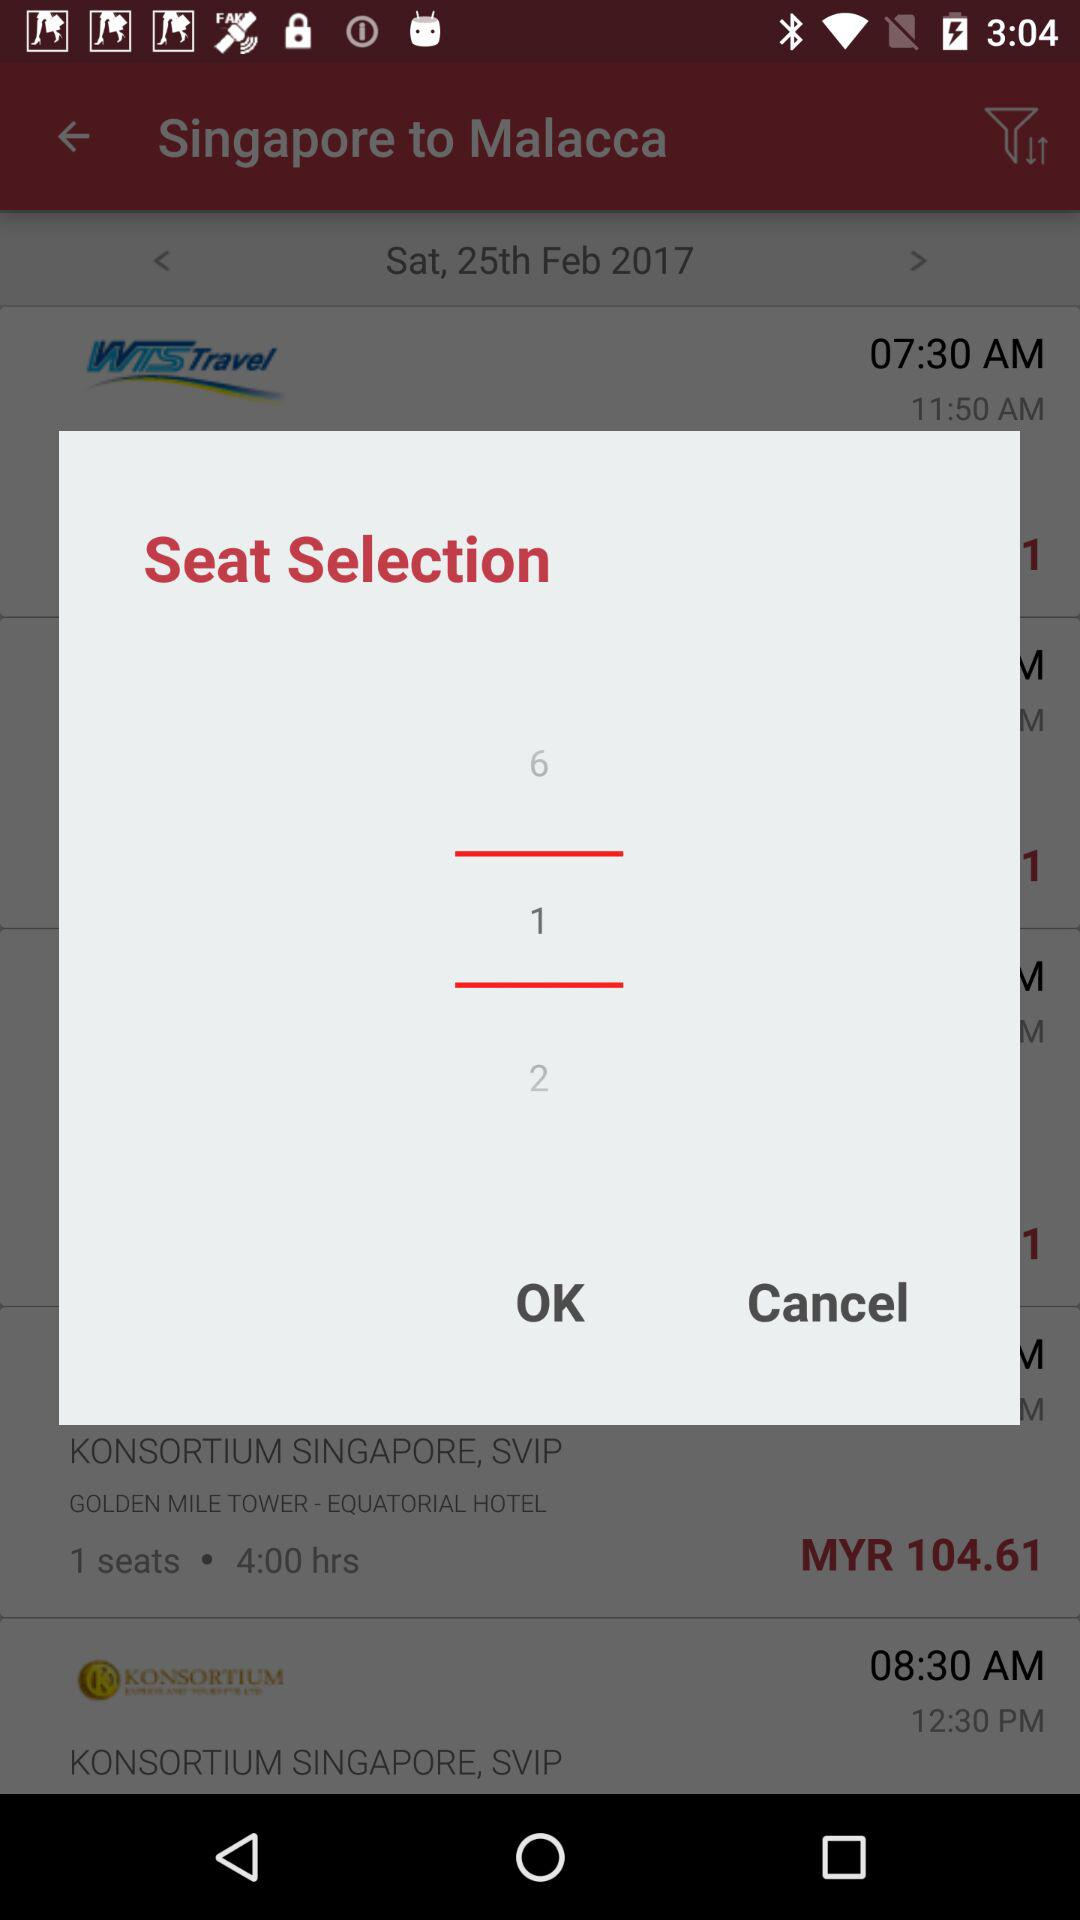How many numbers are in the selection?
Answer the question using a single word or phrase. 3 